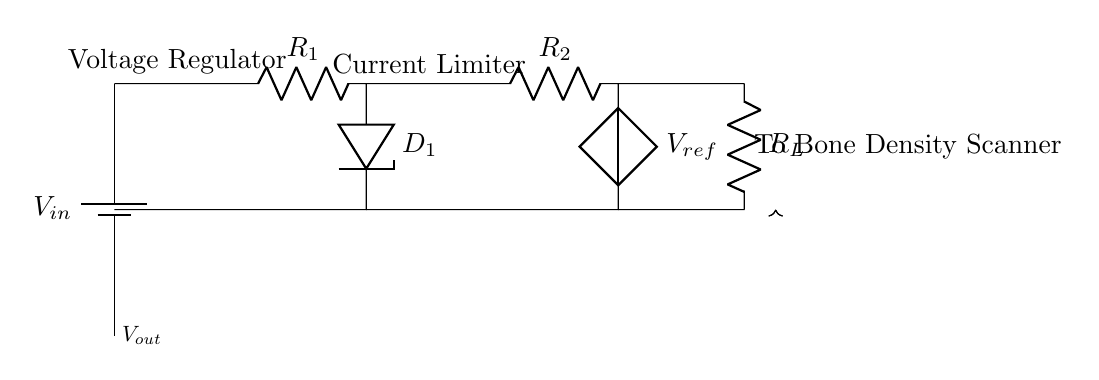What is the input voltage labeled in the circuit? The input voltage is indicated as V-in, which is the first component in the circuit diagram. It is the source voltage that powers the entire circuit.
Answer: V-in What are the two types of regulators shown in this circuit? The circuit includes a voltage regulator and a current limiter. The voltage regulator stabilizes the output voltage, while the current limiter restricts the maximum output current.
Answer: Voltage regulator and current limiter What is the function of the component labeled D1? The component labeled D1 is a diode, which typically allows current to flow in one direction and helps protect the circuit from reverse voltage that can damage components.
Answer: Diode What is the resistance value of resistor R1 likely used for? Resistor R1 is likely used to set the output voltage in the voltage regulator by creating a voltage drop based on the current flowing through it. It helps determine the output voltage.
Answer: Set output voltage How does this circuit ensure safe operation of the bone density scanner? The circuit ensures safe operation by incorporating a current-limiting feature through resistor R2. This limits the output current to a safe level for the bone density scanner, preventing damage from excessive current.
Answer: Current-limiting feature What does the label V-ref signify in this circuit? The label V-ref signifies the reference voltage for the voltage regulator. It serves as a comparison point to maintain the desired output voltage level under varying load conditions.
Answer: Reference voltage 